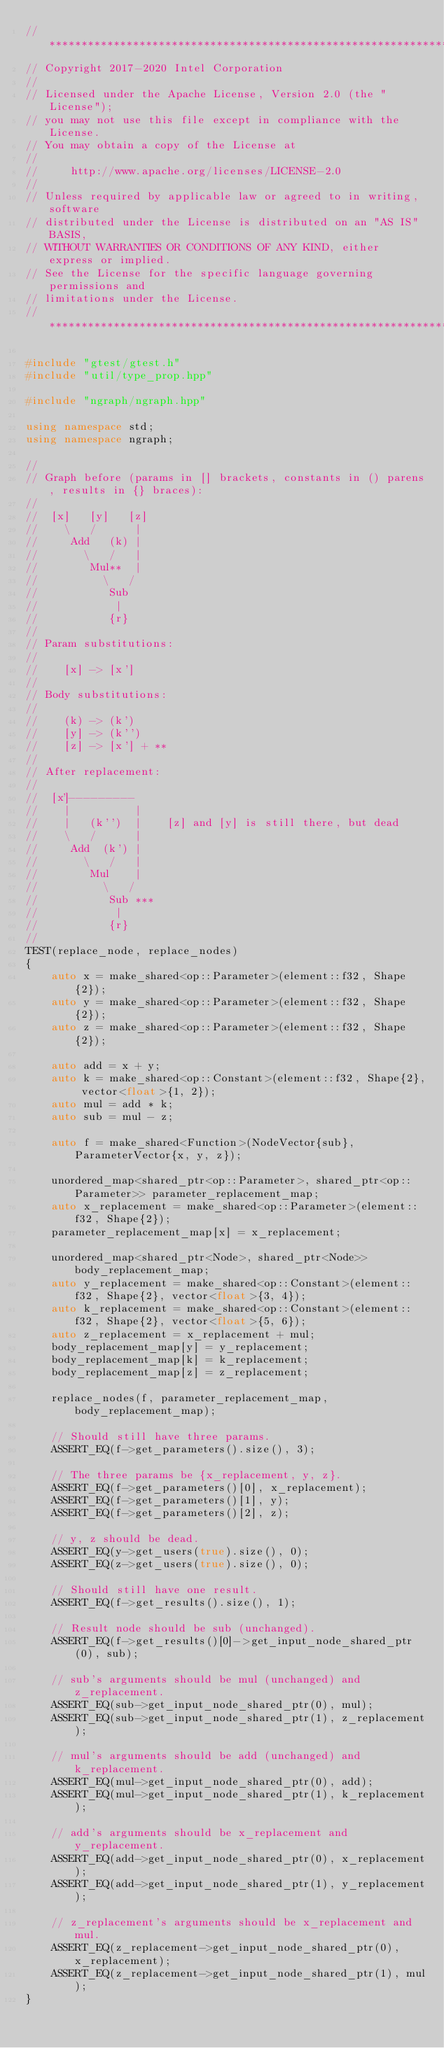Convert code to text. <code><loc_0><loc_0><loc_500><loc_500><_C++_>//*****************************************************************************
// Copyright 2017-2020 Intel Corporation
//
// Licensed under the Apache License, Version 2.0 (the "License");
// you may not use this file except in compliance with the License.
// You may obtain a copy of the License at
//
//     http://www.apache.org/licenses/LICENSE-2.0
//
// Unless required by applicable law or agreed to in writing, software
// distributed under the License is distributed on an "AS IS" BASIS,
// WITHOUT WARRANTIES OR CONDITIONS OF ANY KIND, either express or implied.
// See the License for the specific language governing permissions and
// limitations under the License.
//*****************************************************************************

#include "gtest/gtest.h"
#include "util/type_prop.hpp"

#include "ngraph/ngraph.hpp"

using namespace std;
using namespace ngraph;

//
// Graph before (params in [] brackets, constants in () parens, results in {} braces):
//
//  [x]   [y]   [z]
//    \   /      |
//     Add   (k) |
//       \   /   |
//        Mul**  |
//          \   /
//           Sub
//            |
//           {r}
//
// Param substitutions:
//
//    [x] -> [x']
//
// Body substitutions:
//
//    (k) -> (k')
//    [y] -> (k'')
//    [z] -> [x'] + **
//
// After replacement:
//
//  [x']---------
//    |          |
//    |   (k'')  |    [z] and [y] is still there, but dead
//    \   /      |
//     Add  (k') |
//       \   /   |
//        Mul    |
//          \   /
//           Sub ***
//            |
//           {r}
//
TEST(replace_node, replace_nodes)
{
    auto x = make_shared<op::Parameter>(element::f32, Shape{2});
    auto y = make_shared<op::Parameter>(element::f32, Shape{2});
    auto z = make_shared<op::Parameter>(element::f32, Shape{2});

    auto add = x + y;
    auto k = make_shared<op::Constant>(element::f32, Shape{2}, vector<float>{1, 2});
    auto mul = add * k;
    auto sub = mul - z;

    auto f = make_shared<Function>(NodeVector{sub}, ParameterVector{x, y, z});

    unordered_map<shared_ptr<op::Parameter>, shared_ptr<op::Parameter>> parameter_replacement_map;
    auto x_replacement = make_shared<op::Parameter>(element::f32, Shape{2});
    parameter_replacement_map[x] = x_replacement;

    unordered_map<shared_ptr<Node>, shared_ptr<Node>> body_replacement_map;
    auto y_replacement = make_shared<op::Constant>(element::f32, Shape{2}, vector<float>{3, 4});
    auto k_replacement = make_shared<op::Constant>(element::f32, Shape{2}, vector<float>{5, 6});
    auto z_replacement = x_replacement + mul;
    body_replacement_map[y] = y_replacement;
    body_replacement_map[k] = k_replacement;
    body_replacement_map[z] = z_replacement;

    replace_nodes(f, parameter_replacement_map, body_replacement_map);

    // Should still have three params.
    ASSERT_EQ(f->get_parameters().size(), 3);

    // The three params be {x_replacement, y, z}.
    ASSERT_EQ(f->get_parameters()[0], x_replacement);
    ASSERT_EQ(f->get_parameters()[1], y);
    ASSERT_EQ(f->get_parameters()[2], z);

    // y, z should be dead.
    ASSERT_EQ(y->get_users(true).size(), 0);
    ASSERT_EQ(z->get_users(true).size(), 0);

    // Should still have one result.
    ASSERT_EQ(f->get_results().size(), 1);

    // Result node should be sub (unchanged).
    ASSERT_EQ(f->get_results()[0]->get_input_node_shared_ptr(0), sub);

    // sub's arguments should be mul (unchanged) and z_replacement.
    ASSERT_EQ(sub->get_input_node_shared_ptr(0), mul);
    ASSERT_EQ(sub->get_input_node_shared_ptr(1), z_replacement);

    // mul's arguments should be add (unchanged) and k_replacement.
    ASSERT_EQ(mul->get_input_node_shared_ptr(0), add);
    ASSERT_EQ(mul->get_input_node_shared_ptr(1), k_replacement);

    // add's arguments should be x_replacement and y_replacement.
    ASSERT_EQ(add->get_input_node_shared_ptr(0), x_replacement);
    ASSERT_EQ(add->get_input_node_shared_ptr(1), y_replacement);

    // z_replacement's arguments should be x_replacement and mul.
    ASSERT_EQ(z_replacement->get_input_node_shared_ptr(0), x_replacement);
    ASSERT_EQ(z_replacement->get_input_node_shared_ptr(1), mul);
}
</code> 